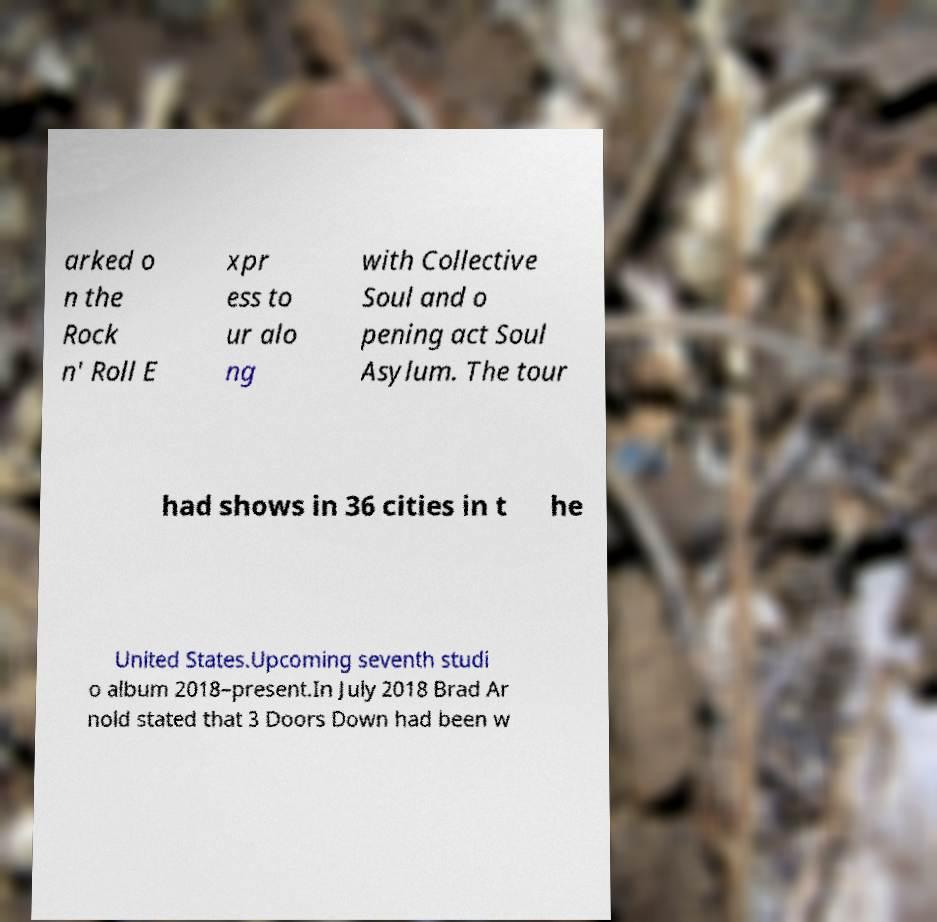For documentation purposes, I need the text within this image transcribed. Could you provide that? arked o n the Rock n' Roll E xpr ess to ur alo ng with Collective Soul and o pening act Soul Asylum. The tour had shows in 36 cities in t he United States.Upcoming seventh studi o album 2018–present.In July 2018 Brad Ar nold stated that 3 Doors Down had been w 